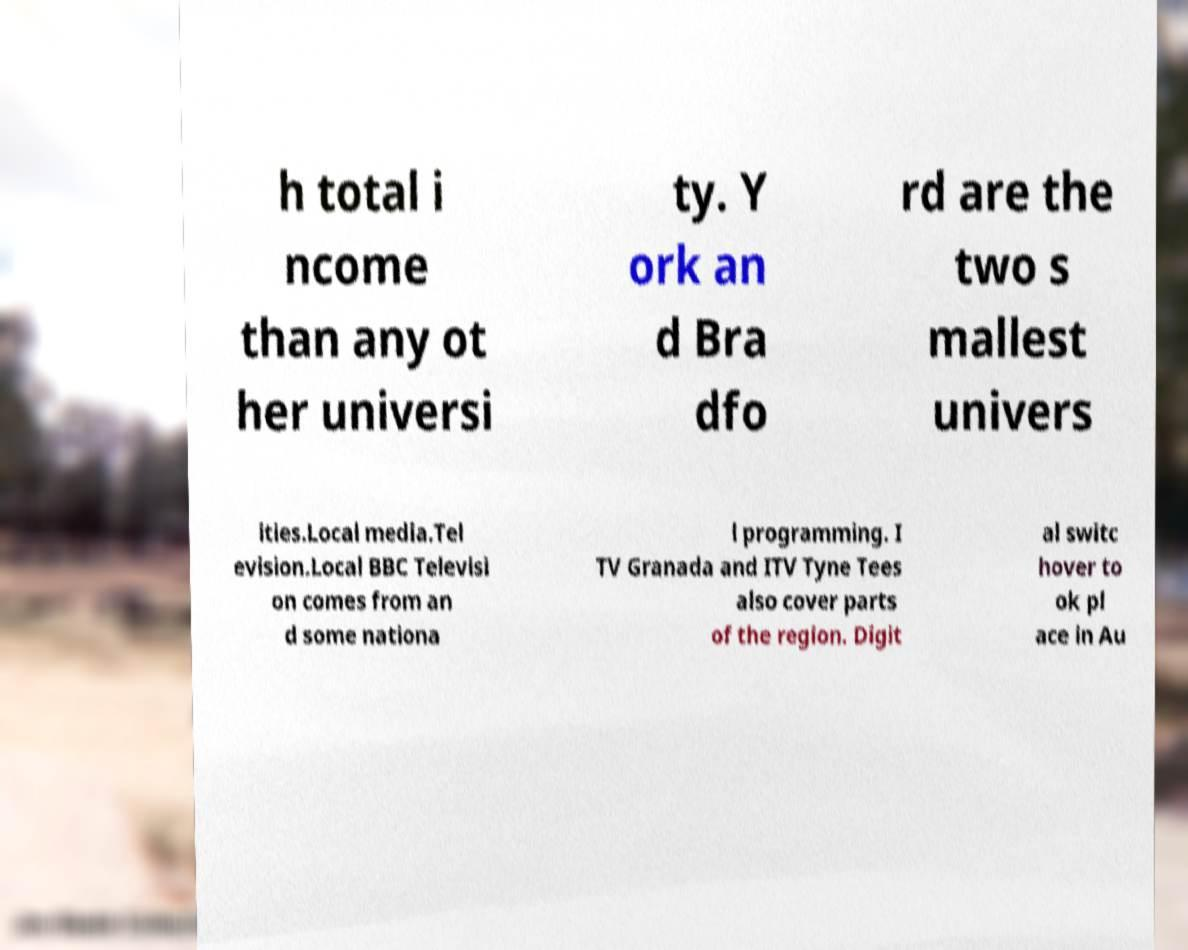Can you read and provide the text displayed in the image?This photo seems to have some interesting text. Can you extract and type it out for me? h total i ncome than any ot her universi ty. Y ork an d Bra dfo rd are the two s mallest univers ities.Local media.Tel evision.Local BBC Televisi on comes from an d some nationa l programming. I TV Granada and ITV Tyne Tees also cover parts of the region. Digit al switc hover to ok pl ace in Au 